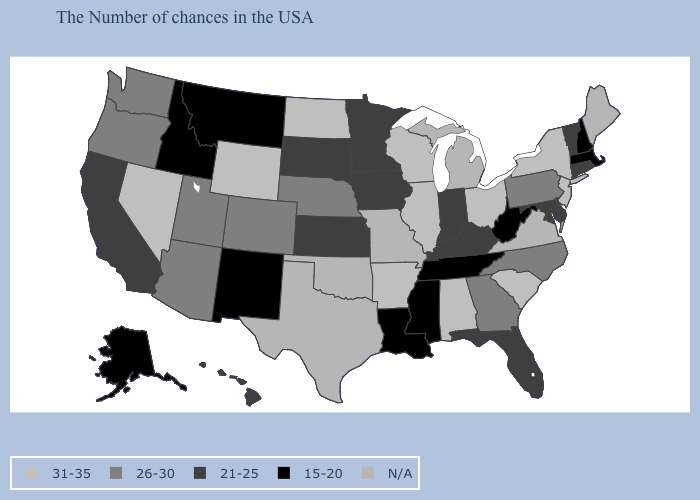Which states hav the highest value in the South?
Write a very short answer. South Carolina, Alabama, Arkansas. What is the lowest value in the USA?
Write a very short answer. 15-20. Is the legend a continuous bar?
Keep it brief. No. What is the value of Texas?
Give a very brief answer. N/A. What is the lowest value in states that border Kentucky?
Short answer required. 15-20. Does the map have missing data?
Write a very short answer. Yes. Does Arkansas have the highest value in the South?
Quick response, please. Yes. Is the legend a continuous bar?
Keep it brief. No. What is the value of Iowa?
Keep it brief. 21-25. Name the states that have a value in the range 15-20?
Be succinct. Massachusetts, New Hampshire, West Virginia, Tennessee, Mississippi, Louisiana, New Mexico, Montana, Idaho, Alaska. What is the value of Hawaii?
Write a very short answer. 21-25. Name the states that have a value in the range 26-30?
Write a very short answer. Pennsylvania, North Carolina, Georgia, Nebraska, Colorado, Utah, Arizona, Washington, Oregon. 